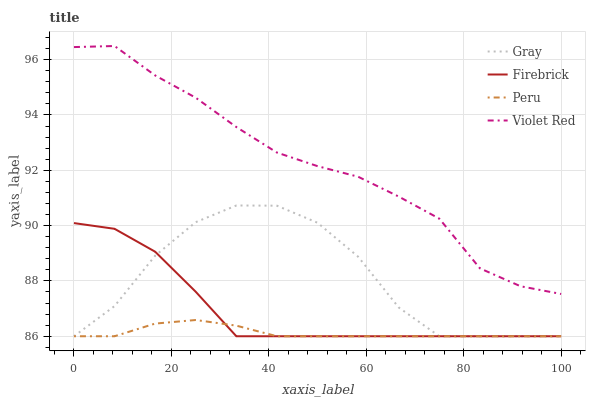Does Peru have the minimum area under the curve?
Answer yes or no. Yes. Does Violet Red have the maximum area under the curve?
Answer yes or no. Yes. Does Firebrick have the minimum area under the curve?
Answer yes or no. No. Does Firebrick have the maximum area under the curve?
Answer yes or no. No. Is Peru the smoothest?
Answer yes or no. Yes. Is Gray the roughest?
Answer yes or no. Yes. Is Firebrick the smoothest?
Answer yes or no. No. Is Firebrick the roughest?
Answer yes or no. No. Does Gray have the lowest value?
Answer yes or no. Yes. Does Violet Red have the lowest value?
Answer yes or no. No. Does Violet Red have the highest value?
Answer yes or no. Yes. Does Firebrick have the highest value?
Answer yes or no. No. Is Firebrick less than Violet Red?
Answer yes or no. Yes. Is Violet Red greater than Peru?
Answer yes or no. Yes. Does Peru intersect Gray?
Answer yes or no. Yes. Is Peru less than Gray?
Answer yes or no. No. Is Peru greater than Gray?
Answer yes or no. No. Does Firebrick intersect Violet Red?
Answer yes or no. No. 